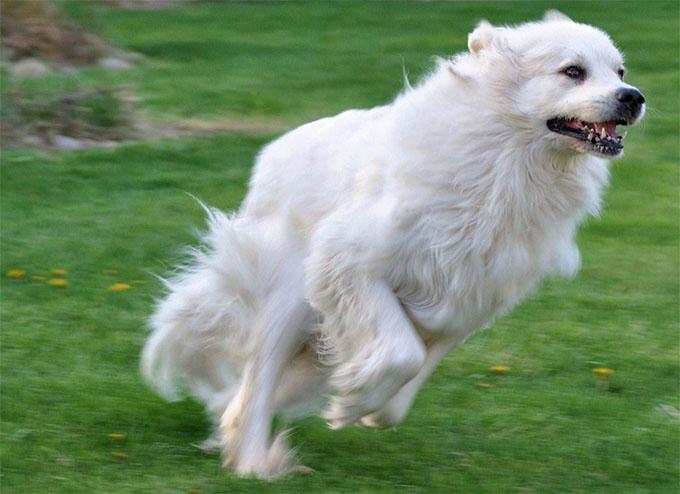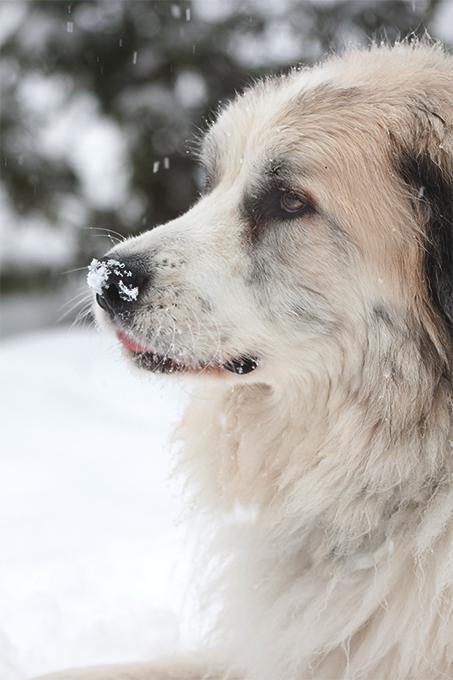The first image is the image on the left, the second image is the image on the right. Evaluate the accuracy of this statement regarding the images: "One of the dogs is sitting with its legs extended on the ground.". Is it true? Answer yes or no. No. The first image is the image on the left, the second image is the image on the right. For the images displayed, is the sentence "the right image has mountains in the background" factually correct? Answer yes or no. No. The first image is the image on the left, the second image is the image on the right. Assess this claim about the two images: "There is one dog facing right in the left image.". Correct or not? Answer yes or no. Yes. 